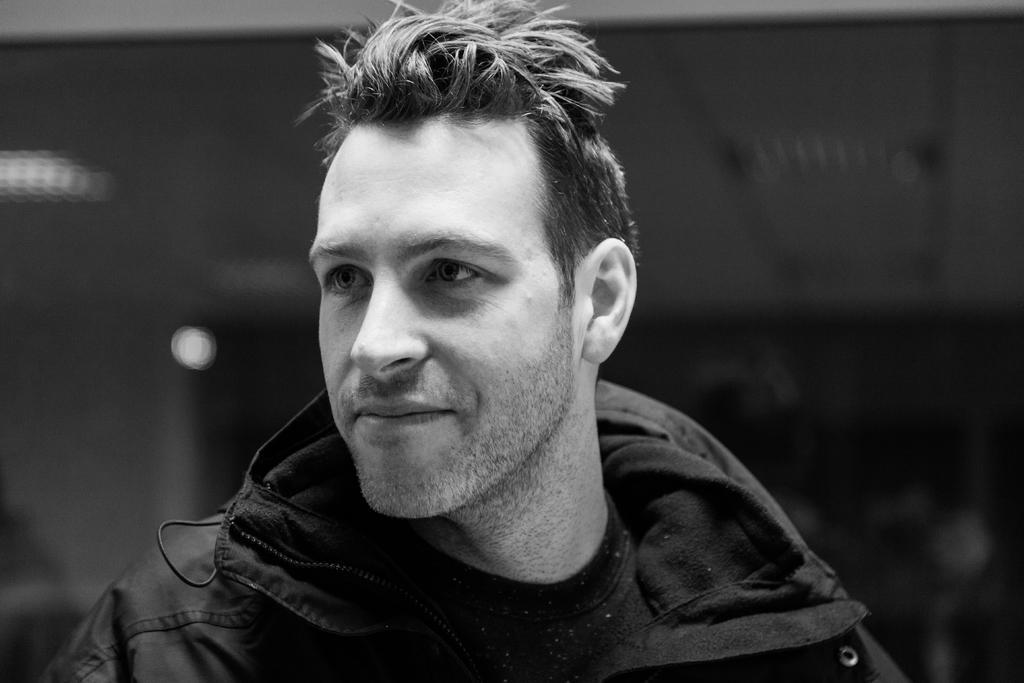Please provide a concise description of this image. In the foreground of this black and white image, there is a man and the background image is blur. 